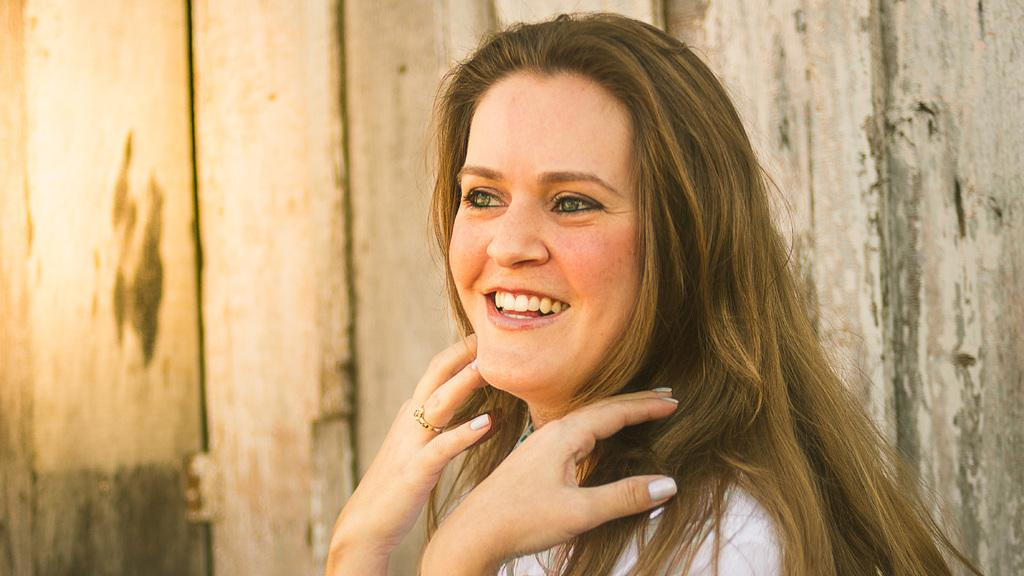Who is present in the image? There is a woman in the image. What is the woman's expression in the image? The woman is smiling in the image. What can be seen in the background of the image? There is a wooden wall in the background of the image. What type of planes can be seen flying in the image? There are no planes visible in the image; it features a woman smiling in front of a wooden wall. What discovery was made by the woman in the image? There is no indication of a discovery in the image; it simply shows a woman smiling. 